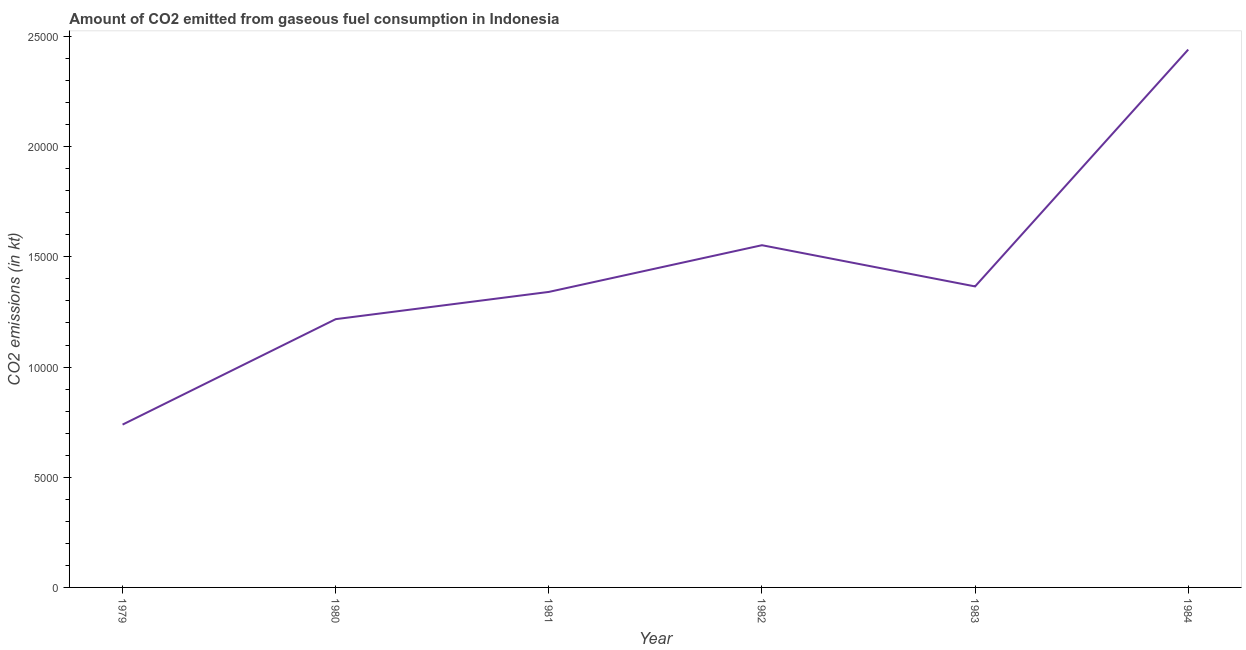What is the co2 emissions from gaseous fuel consumption in 1981?
Make the answer very short. 1.34e+04. Across all years, what is the maximum co2 emissions from gaseous fuel consumption?
Provide a short and direct response. 2.44e+04. Across all years, what is the minimum co2 emissions from gaseous fuel consumption?
Provide a short and direct response. 7389.01. In which year was the co2 emissions from gaseous fuel consumption maximum?
Provide a succinct answer. 1984. In which year was the co2 emissions from gaseous fuel consumption minimum?
Offer a terse response. 1979. What is the sum of the co2 emissions from gaseous fuel consumption?
Your answer should be very brief. 8.66e+04. What is the difference between the co2 emissions from gaseous fuel consumption in 1979 and 1980?
Your response must be concise. -4785.44. What is the average co2 emissions from gaseous fuel consumption per year?
Ensure brevity in your answer.  1.44e+04. What is the median co2 emissions from gaseous fuel consumption?
Offer a terse response. 1.35e+04. In how many years, is the co2 emissions from gaseous fuel consumption greater than 6000 kt?
Offer a terse response. 6. What is the ratio of the co2 emissions from gaseous fuel consumption in 1980 to that in 1984?
Make the answer very short. 0.5. What is the difference between the highest and the second highest co2 emissions from gaseous fuel consumption?
Give a very brief answer. 8877.81. What is the difference between the highest and the lowest co2 emissions from gaseous fuel consumption?
Your response must be concise. 1.70e+04. In how many years, is the co2 emissions from gaseous fuel consumption greater than the average co2 emissions from gaseous fuel consumption taken over all years?
Your response must be concise. 2. Does the co2 emissions from gaseous fuel consumption monotonically increase over the years?
Your answer should be compact. No. How many lines are there?
Ensure brevity in your answer.  1. What is the difference between two consecutive major ticks on the Y-axis?
Offer a terse response. 5000. Are the values on the major ticks of Y-axis written in scientific E-notation?
Keep it short and to the point. No. What is the title of the graph?
Your response must be concise. Amount of CO2 emitted from gaseous fuel consumption in Indonesia. What is the label or title of the Y-axis?
Your answer should be very brief. CO2 emissions (in kt). What is the CO2 emissions (in kt) in 1979?
Provide a short and direct response. 7389.01. What is the CO2 emissions (in kt) of 1980?
Keep it short and to the point. 1.22e+04. What is the CO2 emissions (in kt) in 1981?
Offer a very short reply. 1.34e+04. What is the CO2 emissions (in kt) of 1982?
Offer a terse response. 1.55e+04. What is the CO2 emissions (in kt) in 1983?
Provide a succinct answer. 1.37e+04. What is the CO2 emissions (in kt) of 1984?
Provide a succinct answer. 2.44e+04. What is the difference between the CO2 emissions (in kt) in 1979 and 1980?
Ensure brevity in your answer.  -4785.44. What is the difference between the CO2 emissions (in kt) in 1979 and 1981?
Make the answer very short. -6021.21. What is the difference between the CO2 emissions (in kt) in 1979 and 1982?
Offer a terse response. -8140.74. What is the difference between the CO2 emissions (in kt) in 1979 and 1983?
Provide a succinct answer. -6270.57. What is the difference between the CO2 emissions (in kt) in 1979 and 1984?
Give a very brief answer. -1.70e+04. What is the difference between the CO2 emissions (in kt) in 1980 and 1981?
Your answer should be very brief. -1235.78. What is the difference between the CO2 emissions (in kt) in 1980 and 1982?
Make the answer very short. -3355.3. What is the difference between the CO2 emissions (in kt) in 1980 and 1983?
Offer a very short reply. -1485.13. What is the difference between the CO2 emissions (in kt) in 1980 and 1984?
Ensure brevity in your answer.  -1.22e+04. What is the difference between the CO2 emissions (in kt) in 1981 and 1982?
Provide a short and direct response. -2119.53. What is the difference between the CO2 emissions (in kt) in 1981 and 1983?
Provide a short and direct response. -249.36. What is the difference between the CO2 emissions (in kt) in 1981 and 1984?
Keep it short and to the point. -1.10e+04. What is the difference between the CO2 emissions (in kt) in 1982 and 1983?
Your answer should be very brief. 1870.17. What is the difference between the CO2 emissions (in kt) in 1982 and 1984?
Your response must be concise. -8877.81. What is the difference between the CO2 emissions (in kt) in 1983 and 1984?
Give a very brief answer. -1.07e+04. What is the ratio of the CO2 emissions (in kt) in 1979 to that in 1980?
Offer a very short reply. 0.61. What is the ratio of the CO2 emissions (in kt) in 1979 to that in 1981?
Your answer should be very brief. 0.55. What is the ratio of the CO2 emissions (in kt) in 1979 to that in 1982?
Provide a succinct answer. 0.48. What is the ratio of the CO2 emissions (in kt) in 1979 to that in 1983?
Provide a succinct answer. 0.54. What is the ratio of the CO2 emissions (in kt) in 1979 to that in 1984?
Make the answer very short. 0.3. What is the ratio of the CO2 emissions (in kt) in 1980 to that in 1981?
Provide a succinct answer. 0.91. What is the ratio of the CO2 emissions (in kt) in 1980 to that in 1982?
Provide a short and direct response. 0.78. What is the ratio of the CO2 emissions (in kt) in 1980 to that in 1983?
Give a very brief answer. 0.89. What is the ratio of the CO2 emissions (in kt) in 1980 to that in 1984?
Give a very brief answer. 0.5. What is the ratio of the CO2 emissions (in kt) in 1981 to that in 1982?
Your response must be concise. 0.86. What is the ratio of the CO2 emissions (in kt) in 1981 to that in 1984?
Offer a terse response. 0.55. What is the ratio of the CO2 emissions (in kt) in 1982 to that in 1983?
Provide a short and direct response. 1.14. What is the ratio of the CO2 emissions (in kt) in 1982 to that in 1984?
Your response must be concise. 0.64. What is the ratio of the CO2 emissions (in kt) in 1983 to that in 1984?
Ensure brevity in your answer.  0.56. 